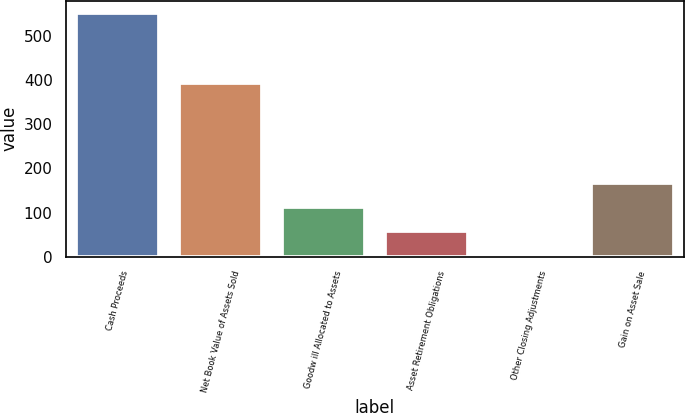Convert chart to OTSL. <chart><loc_0><loc_0><loc_500><loc_500><bar_chart><fcel>Cash Proceeds<fcel>Net Book Value of Assets Sold<fcel>Goodw ill Allocated to Assets<fcel>Asset Retirement Obligations<fcel>Other Closing Adjustments<fcel>Gain on Asset Sale<nl><fcel>552<fcel>394<fcel>112.8<fcel>57.9<fcel>3<fcel>167.7<nl></chart> 